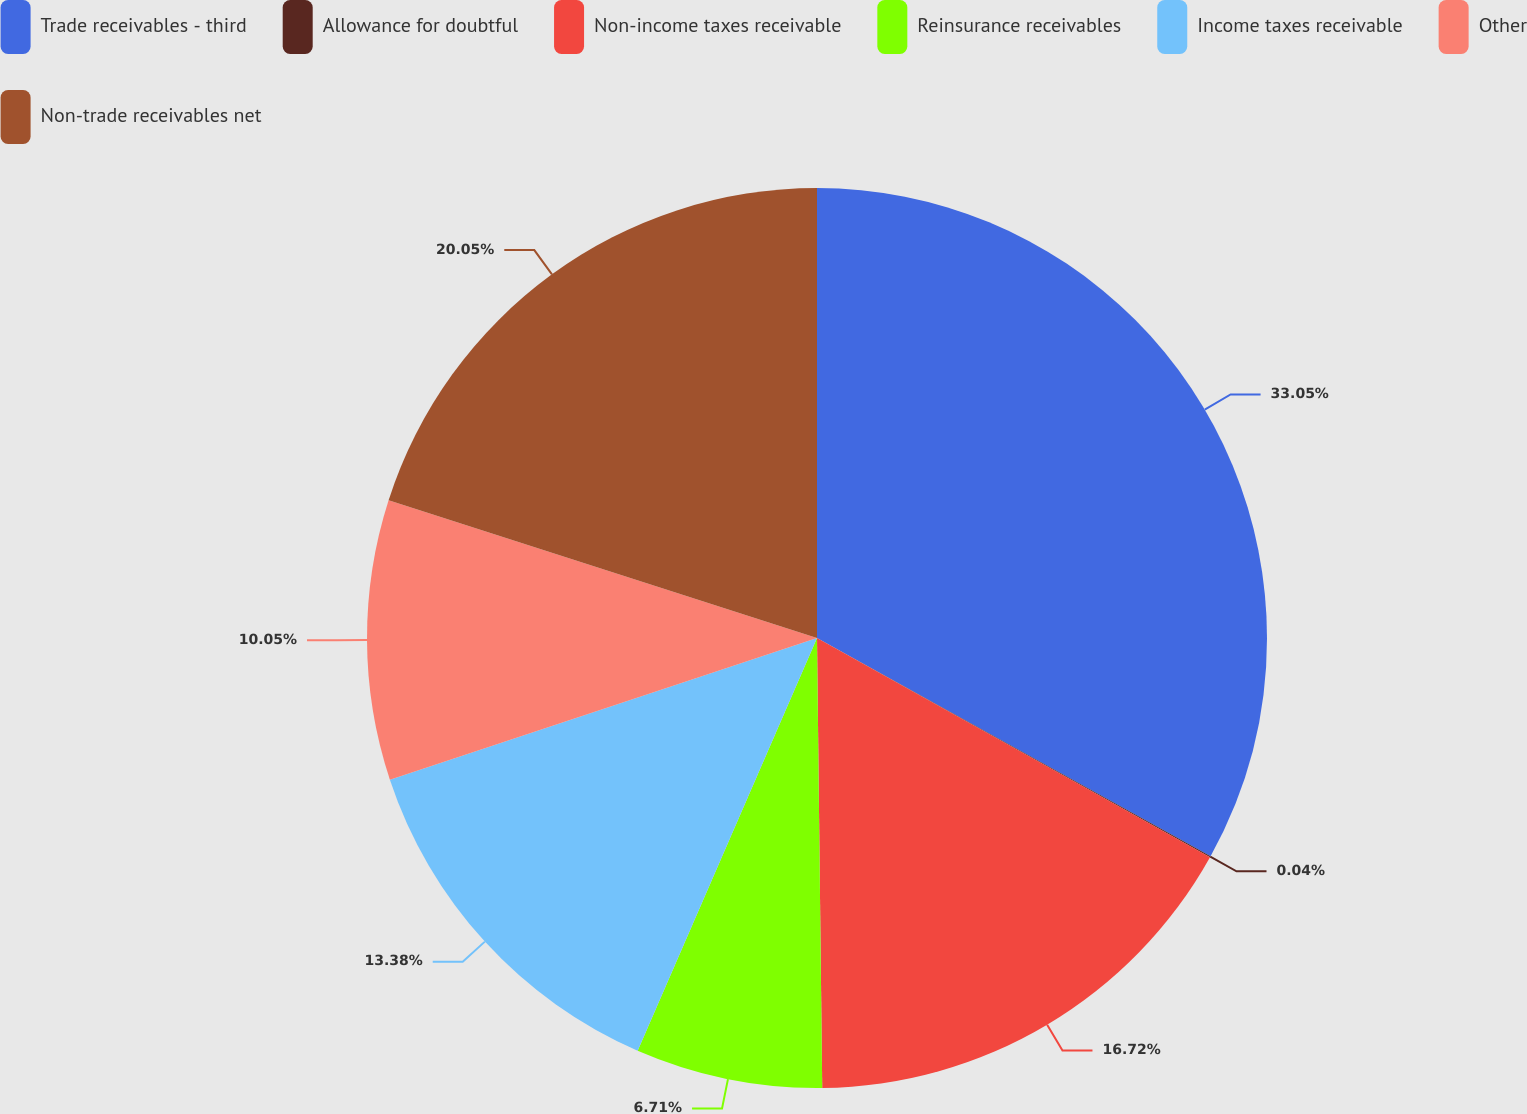<chart> <loc_0><loc_0><loc_500><loc_500><pie_chart><fcel>Trade receivables - third<fcel>Allowance for doubtful<fcel>Non-income taxes receivable<fcel>Reinsurance receivables<fcel>Income taxes receivable<fcel>Other<fcel>Non-trade receivables net<nl><fcel>33.06%<fcel>0.04%<fcel>16.72%<fcel>6.71%<fcel>13.38%<fcel>10.05%<fcel>20.05%<nl></chart> 